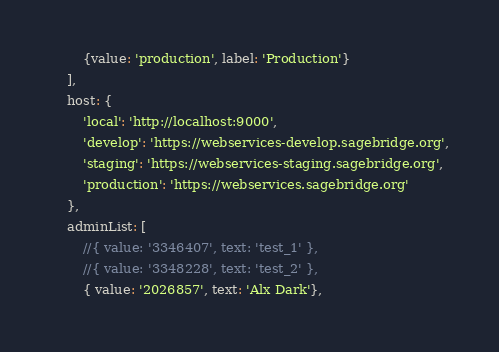<code> <loc_0><loc_0><loc_500><loc_500><_JavaScript_>        {value: 'production', label: 'Production'}
    ],
    host: {
        'local': 'http://localhost:9000',
        'develop': 'https://webservices-develop.sagebridge.org',
        'staging': 'https://webservices-staging.sagebridge.org',
        'production': 'https://webservices.sagebridge.org'
    },
    adminList: [
        //{ value: '3346407', text: 'test_1' },
        //{ value: '3348228', text: 'test_2' },
        { value: '2026857', text: 'Alx Dark'},</code> 